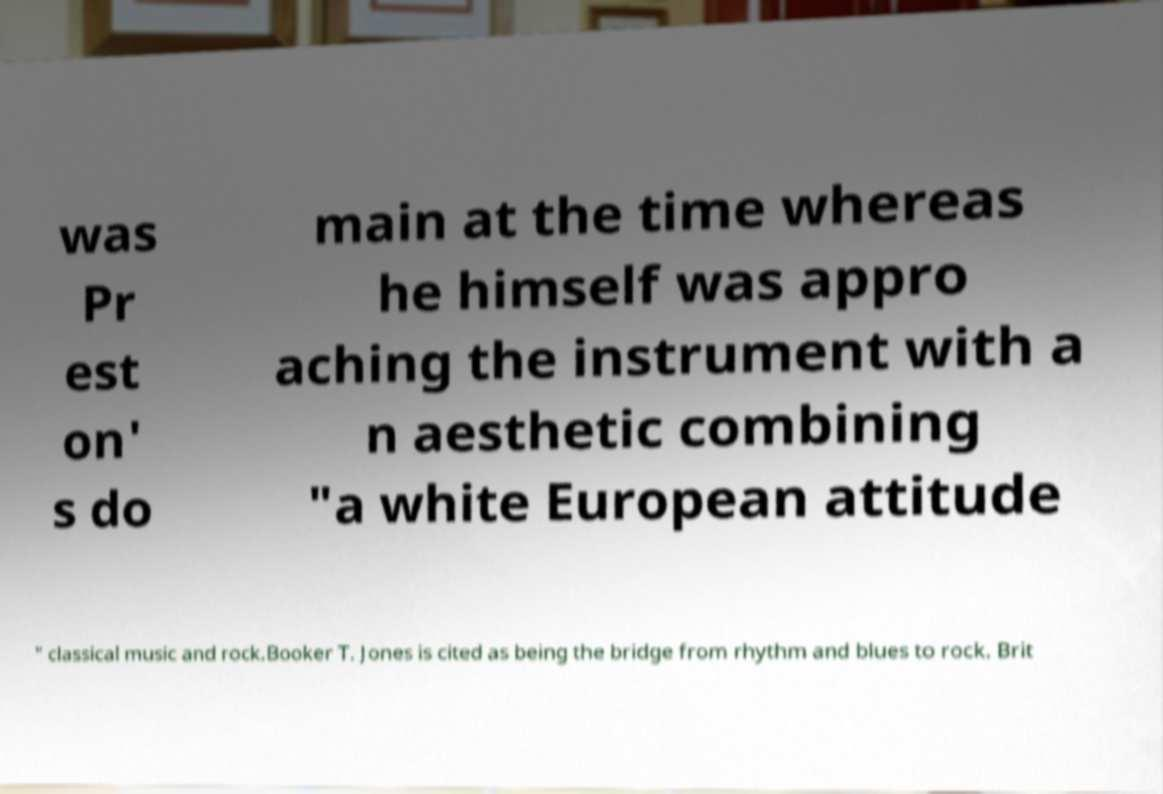There's text embedded in this image that I need extracted. Can you transcribe it verbatim? was Pr est on' s do main at the time whereas he himself was appro aching the instrument with a n aesthetic combining "a white European attitude " classical music and rock.Booker T. Jones is cited as being the bridge from rhythm and blues to rock. Brit 